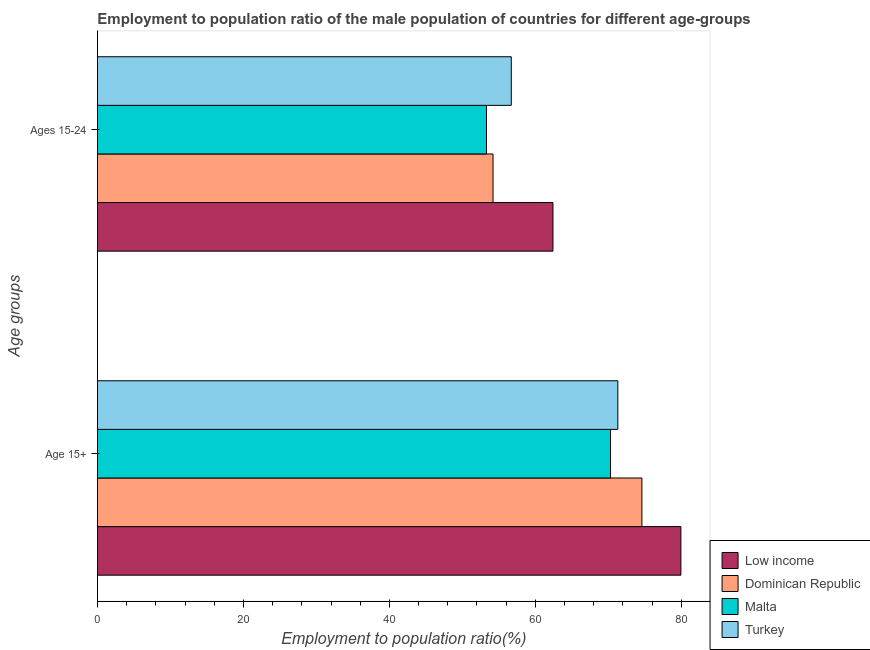How many groups of bars are there?
Your answer should be compact. 2. Are the number of bars per tick equal to the number of legend labels?
Your response must be concise. Yes. How many bars are there on the 2nd tick from the top?
Offer a very short reply. 4. What is the label of the 2nd group of bars from the top?
Ensure brevity in your answer.  Age 15+. What is the employment to population ratio(age 15+) in Dominican Republic?
Give a very brief answer. 74.6. Across all countries, what is the maximum employment to population ratio(age 15-24)?
Provide a short and direct response. 62.41. Across all countries, what is the minimum employment to population ratio(age 15+)?
Make the answer very short. 70.3. In which country was the employment to population ratio(age 15-24) minimum?
Your answer should be very brief. Malta. What is the total employment to population ratio(age 15-24) in the graph?
Your response must be concise. 226.61. What is the difference between the employment to population ratio(age 15+) in Dominican Republic and the employment to population ratio(age 15-24) in Malta?
Make the answer very short. 21.3. What is the average employment to population ratio(age 15-24) per country?
Your answer should be very brief. 56.65. What is the difference between the employment to population ratio(age 15-24) and employment to population ratio(age 15+) in Low income?
Provide a succinct answer. -17.53. What is the ratio of the employment to population ratio(age 15-24) in Dominican Republic to that in Low income?
Give a very brief answer. 0.87. In how many countries, is the employment to population ratio(age 15-24) greater than the average employment to population ratio(age 15-24) taken over all countries?
Provide a short and direct response. 2. Are all the bars in the graph horizontal?
Your answer should be compact. Yes. How many countries are there in the graph?
Ensure brevity in your answer.  4. Does the graph contain grids?
Provide a short and direct response. No. Where does the legend appear in the graph?
Give a very brief answer. Bottom right. How many legend labels are there?
Offer a very short reply. 4. How are the legend labels stacked?
Your answer should be very brief. Vertical. What is the title of the graph?
Keep it short and to the point. Employment to population ratio of the male population of countries for different age-groups. What is the label or title of the Y-axis?
Offer a terse response. Age groups. What is the Employment to population ratio(%) in Low income in Age 15+?
Make the answer very short. 79.94. What is the Employment to population ratio(%) of Dominican Republic in Age 15+?
Make the answer very short. 74.6. What is the Employment to population ratio(%) of Malta in Age 15+?
Your answer should be compact. 70.3. What is the Employment to population ratio(%) of Turkey in Age 15+?
Give a very brief answer. 71.3. What is the Employment to population ratio(%) in Low income in Ages 15-24?
Offer a very short reply. 62.41. What is the Employment to population ratio(%) of Dominican Republic in Ages 15-24?
Keep it short and to the point. 54.2. What is the Employment to population ratio(%) in Malta in Ages 15-24?
Offer a terse response. 53.3. What is the Employment to population ratio(%) in Turkey in Ages 15-24?
Your answer should be compact. 56.7. Across all Age groups, what is the maximum Employment to population ratio(%) in Low income?
Your response must be concise. 79.94. Across all Age groups, what is the maximum Employment to population ratio(%) in Dominican Republic?
Give a very brief answer. 74.6. Across all Age groups, what is the maximum Employment to population ratio(%) in Malta?
Ensure brevity in your answer.  70.3. Across all Age groups, what is the maximum Employment to population ratio(%) in Turkey?
Give a very brief answer. 71.3. Across all Age groups, what is the minimum Employment to population ratio(%) of Low income?
Provide a succinct answer. 62.41. Across all Age groups, what is the minimum Employment to population ratio(%) in Dominican Republic?
Offer a terse response. 54.2. Across all Age groups, what is the minimum Employment to population ratio(%) in Malta?
Offer a terse response. 53.3. Across all Age groups, what is the minimum Employment to population ratio(%) of Turkey?
Offer a terse response. 56.7. What is the total Employment to population ratio(%) of Low income in the graph?
Your answer should be very brief. 142.35. What is the total Employment to population ratio(%) in Dominican Republic in the graph?
Offer a terse response. 128.8. What is the total Employment to population ratio(%) in Malta in the graph?
Your answer should be compact. 123.6. What is the total Employment to population ratio(%) of Turkey in the graph?
Offer a very short reply. 128. What is the difference between the Employment to population ratio(%) of Low income in Age 15+ and that in Ages 15-24?
Your answer should be very brief. 17.53. What is the difference between the Employment to population ratio(%) of Dominican Republic in Age 15+ and that in Ages 15-24?
Provide a succinct answer. 20.4. What is the difference between the Employment to population ratio(%) in Low income in Age 15+ and the Employment to population ratio(%) in Dominican Republic in Ages 15-24?
Ensure brevity in your answer.  25.74. What is the difference between the Employment to population ratio(%) in Low income in Age 15+ and the Employment to population ratio(%) in Malta in Ages 15-24?
Offer a terse response. 26.64. What is the difference between the Employment to population ratio(%) in Low income in Age 15+ and the Employment to population ratio(%) in Turkey in Ages 15-24?
Offer a terse response. 23.24. What is the difference between the Employment to population ratio(%) in Dominican Republic in Age 15+ and the Employment to population ratio(%) in Malta in Ages 15-24?
Offer a very short reply. 21.3. What is the difference between the Employment to population ratio(%) of Dominican Republic in Age 15+ and the Employment to population ratio(%) of Turkey in Ages 15-24?
Provide a short and direct response. 17.9. What is the average Employment to population ratio(%) in Low income per Age groups?
Provide a short and direct response. 71.18. What is the average Employment to population ratio(%) of Dominican Republic per Age groups?
Make the answer very short. 64.4. What is the average Employment to population ratio(%) in Malta per Age groups?
Keep it short and to the point. 61.8. What is the average Employment to population ratio(%) of Turkey per Age groups?
Your response must be concise. 64. What is the difference between the Employment to population ratio(%) in Low income and Employment to population ratio(%) in Dominican Republic in Age 15+?
Offer a very short reply. 5.34. What is the difference between the Employment to population ratio(%) of Low income and Employment to population ratio(%) of Malta in Age 15+?
Provide a short and direct response. 9.64. What is the difference between the Employment to population ratio(%) of Low income and Employment to population ratio(%) of Turkey in Age 15+?
Your answer should be compact. 8.64. What is the difference between the Employment to population ratio(%) of Dominican Republic and Employment to population ratio(%) of Turkey in Age 15+?
Offer a very short reply. 3.3. What is the difference between the Employment to population ratio(%) of Low income and Employment to population ratio(%) of Dominican Republic in Ages 15-24?
Your answer should be compact. 8.21. What is the difference between the Employment to population ratio(%) of Low income and Employment to population ratio(%) of Malta in Ages 15-24?
Your answer should be compact. 9.11. What is the difference between the Employment to population ratio(%) of Low income and Employment to population ratio(%) of Turkey in Ages 15-24?
Make the answer very short. 5.71. What is the difference between the Employment to population ratio(%) in Malta and Employment to population ratio(%) in Turkey in Ages 15-24?
Ensure brevity in your answer.  -3.4. What is the ratio of the Employment to population ratio(%) in Low income in Age 15+ to that in Ages 15-24?
Offer a very short reply. 1.28. What is the ratio of the Employment to population ratio(%) in Dominican Republic in Age 15+ to that in Ages 15-24?
Ensure brevity in your answer.  1.38. What is the ratio of the Employment to population ratio(%) of Malta in Age 15+ to that in Ages 15-24?
Offer a terse response. 1.32. What is the ratio of the Employment to population ratio(%) in Turkey in Age 15+ to that in Ages 15-24?
Your answer should be compact. 1.26. What is the difference between the highest and the second highest Employment to population ratio(%) in Low income?
Your answer should be very brief. 17.53. What is the difference between the highest and the second highest Employment to population ratio(%) of Dominican Republic?
Make the answer very short. 20.4. What is the difference between the highest and the second highest Employment to population ratio(%) of Malta?
Provide a short and direct response. 17. What is the difference between the highest and the second highest Employment to population ratio(%) in Turkey?
Provide a short and direct response. 14.6. What is the difference between the highest and the lowest Employment to population ratio(%) in Low income?
Offer a very short reply. 17.53. What is the difference between the highest and the lowest Employment to population ratio(%) in Dominican Republic?
Your answer should be very brief. 20.4. What is the difference between the highest and the lowest Employment to population ratio(%) in Turkey?
Make the answer very short. 14.6. 